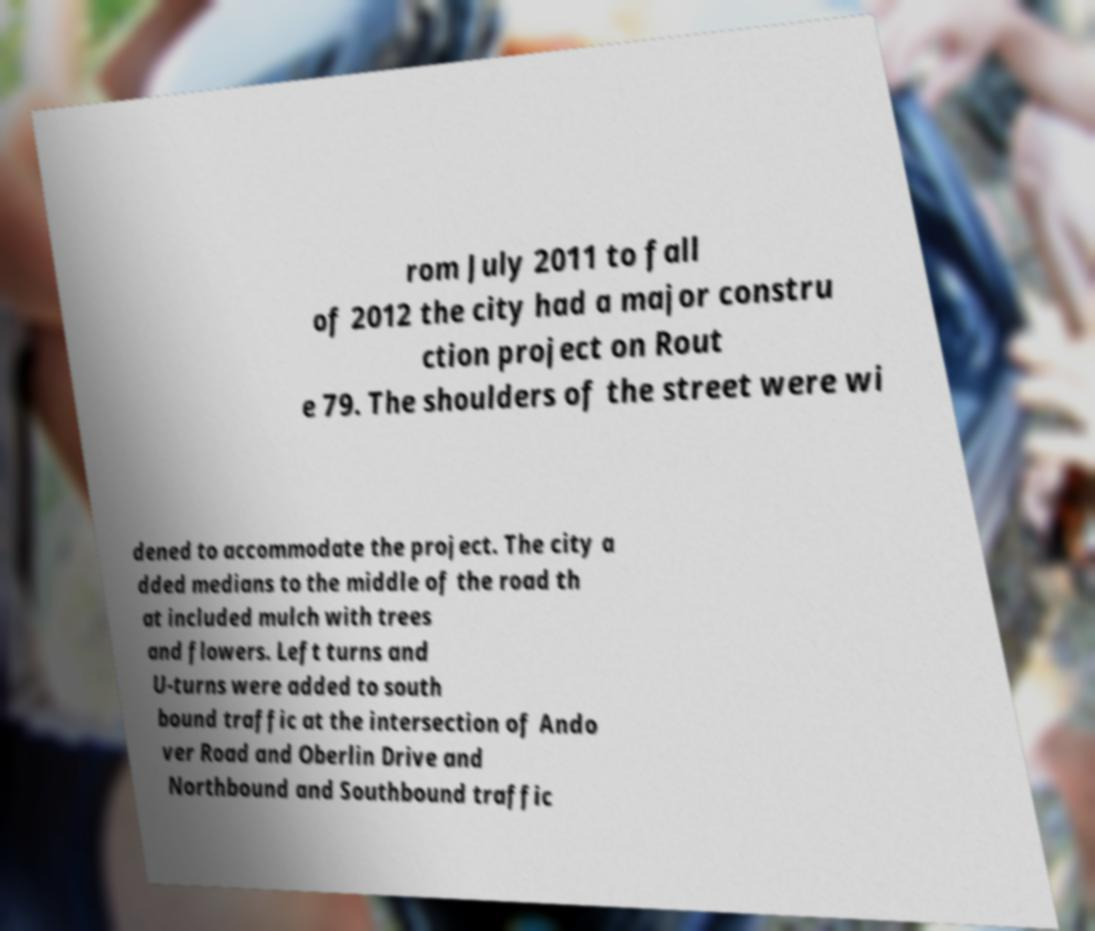Please identify and transcribe the text found in this image. rom July 2011 to fall of 2012 the city had a major constru ction project on Rout e 79. The shoulders of the street were wi dened to accommodate the project. The city a dded medians to the middle of the road th at included mulch with trees and flowers. Left turns and U-turns were added to south bound traffic at the intersection of Ando ver Road and Oberlin Drive and Northbound and Southbound traffic 